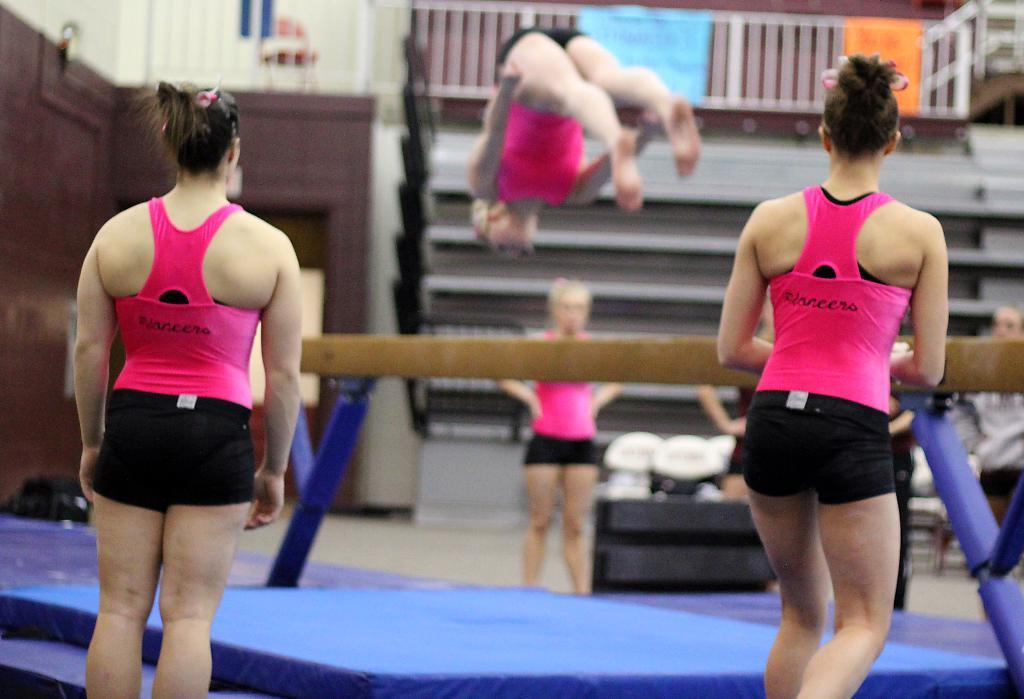What can be seen in the image involving people? There are persons standing in the image. What type of furniture is present in the image? There is a bed in the image. What object is attached to rods in the image? There is a wooden stick attached to rods in the image. What architectural feature is visible in the image? There are stairs visible in the image. What surface is the bed and the people standing on? There is a floor in the image. What type of scarf is being used to control the wooden stick in the image? There is no scarf present in the image, and the wooden stick is not being controlled by any external force. What thoughts are the persons in the image having? The image does not provide information about the thoughts or minds of the persons in the image. 